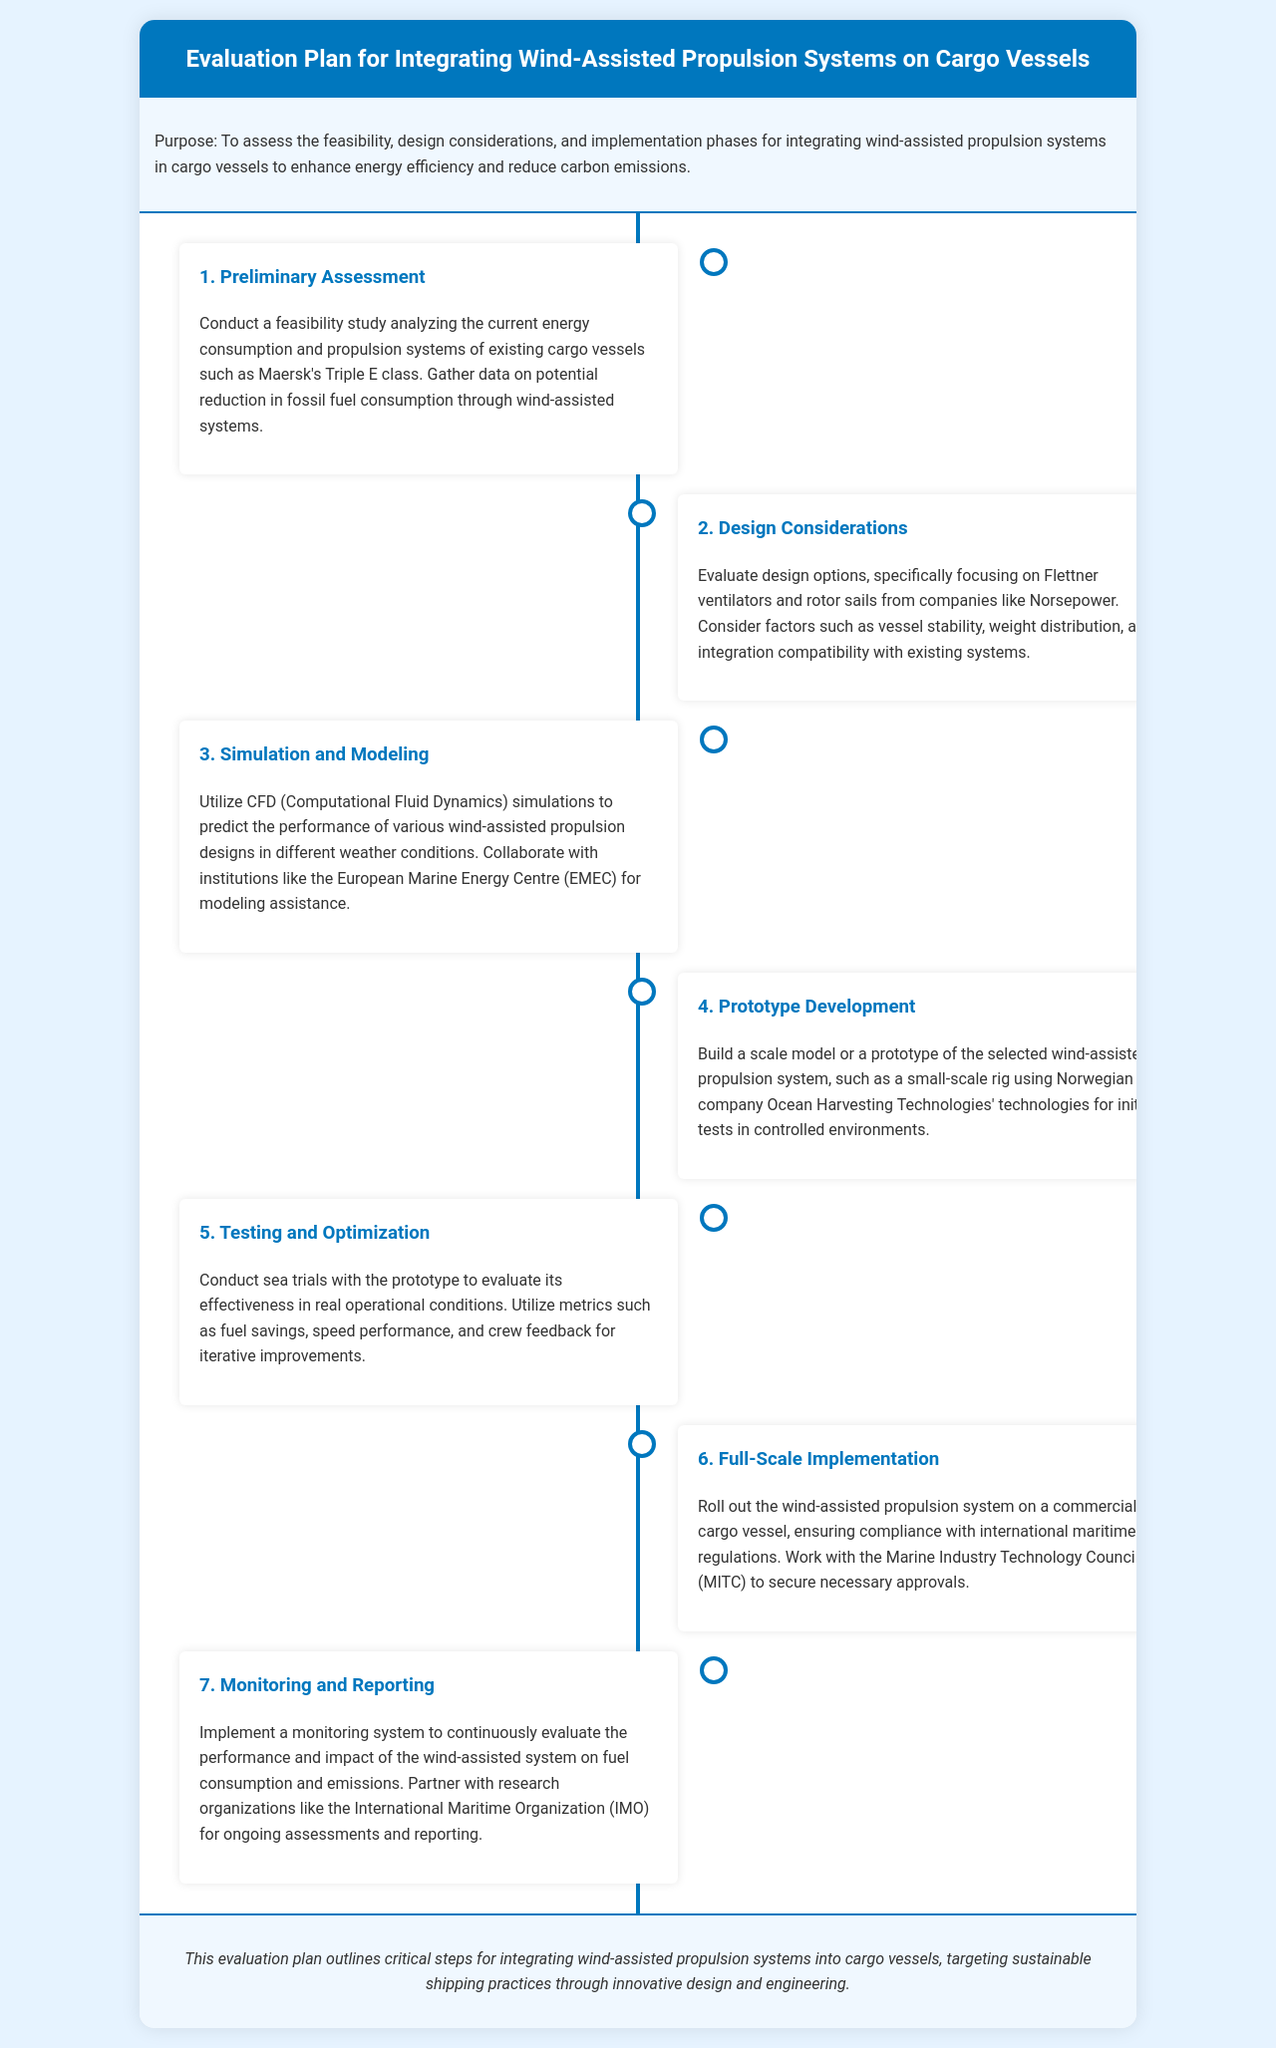What is the purpose of the evaluation plan? The purpose is to assess feasibility, design considerations, and implementation phases for integrating wind-assisted propulsion systems in cargo vessels to enhance energy efficiency and reduce carbon emissions.
Answer: To assess feasibility, design considerations, and implementation phases What is the first phase of the evaluation plan? The first phase mentioned in the document is the Preliminary Assessment, which entails a feasibility study of existing cargo vessels.
Answer: Preliminary Assessment Who needs to be collaborated with for simulation and modeling? The document states collaboration with the European Marine Energy Centre (EMEC) for modeling assistance is needed.
Answer: European Marine Energy Centre (EMEC) What type of technology is suggested for prototype development? The document mentions using technologies from Norwegian company Ocean Harvesting Technologies for prototype development.
Answer: Ocean Harvesting Technologies How many phases are detailed in the evaluation plan? The document outlines a total of seven phases in the evaluation plan.
Answer: Seven What is the focus of the Design Considerations phase? The focus is on evaluating design options including Flettner ventilators and rotor sails, considering stability, weight distribution, and integration compatibility.
Answer: Flettner ventilators and rotor sails What is essential for full-scale implementation of the system? Compliance with international maritime regulations is essential for full-scale implementation according to the document.
Answer: Compliance with international maritime regulations What metric is used for testing and optimization? The document states that metrics such as fuel savings, speed performance, and crew feedback are used for testing and optimization.
Answer: Fuel savings, speed performance, and crew feedback 